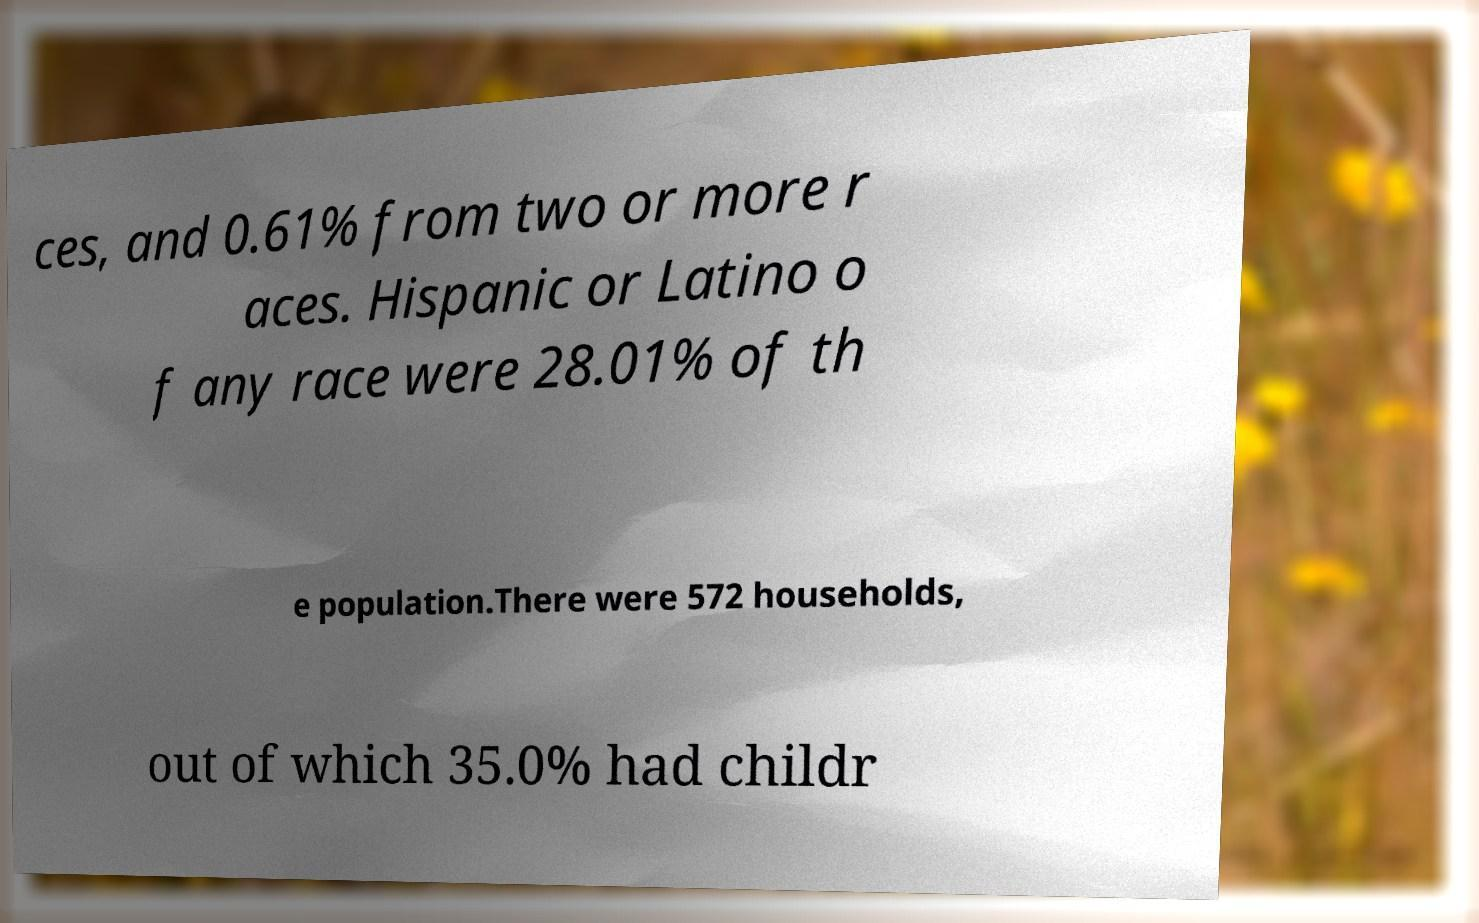Could you extract and type out the text from this image? ces, and 0.61% from two or more r aces. Hispanic or Latino o f any race were 28.01% of th e population.There were 572 households, out of which 35.0% had childr 